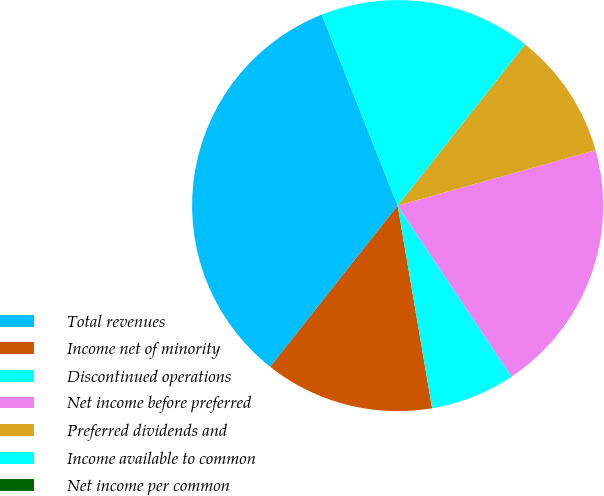Convert chart to OTSL. <chart><loc_0><loc_0><loc_500><loc_500><pie_chart><fcel>Total revenues<fcel>Income net of minority<fcel>Discontinued operations<fcel>Net income before preferred<fcel>Preferred dividends and<fcel>Income available to common<fcel>Net income per common<nl><fcel>33.33%<fcel>13.33%<fcel>6.67%<fcel>20.0%<fcel>10.0%<fcel>16.67%<fcel>0.0%<nl></chart> 